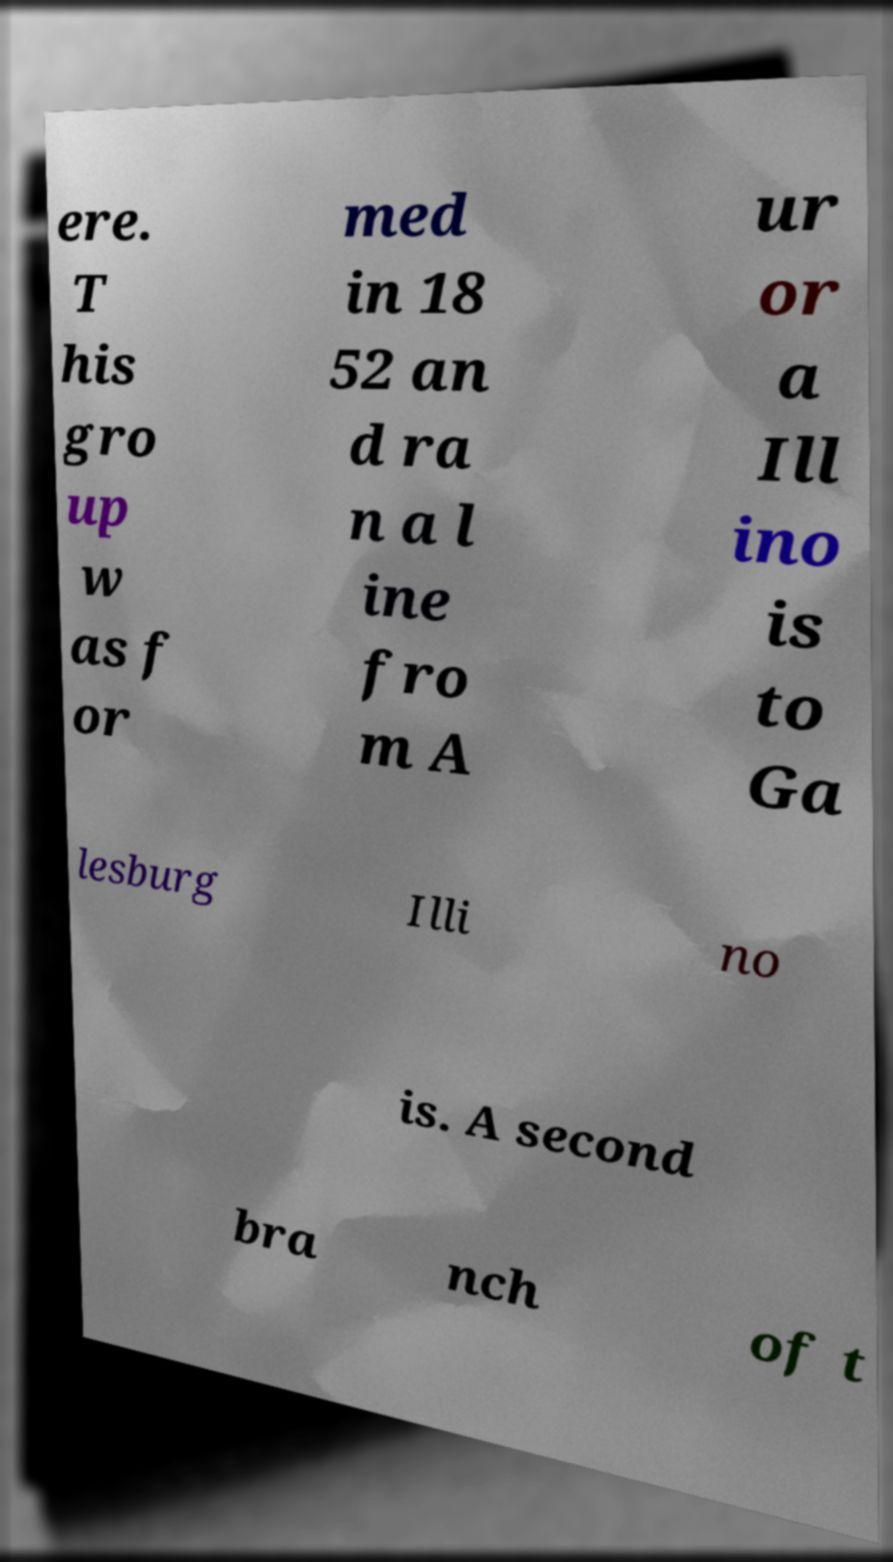There's text embedded in this image that I need extracted. Can you transcribe it verbatim? ere. T his gro up w as f or med in 18 52 an d ra n a l ine fro m A ur or a Ill ino is to Ga lesburg Illi no is. A second bra nch of t 